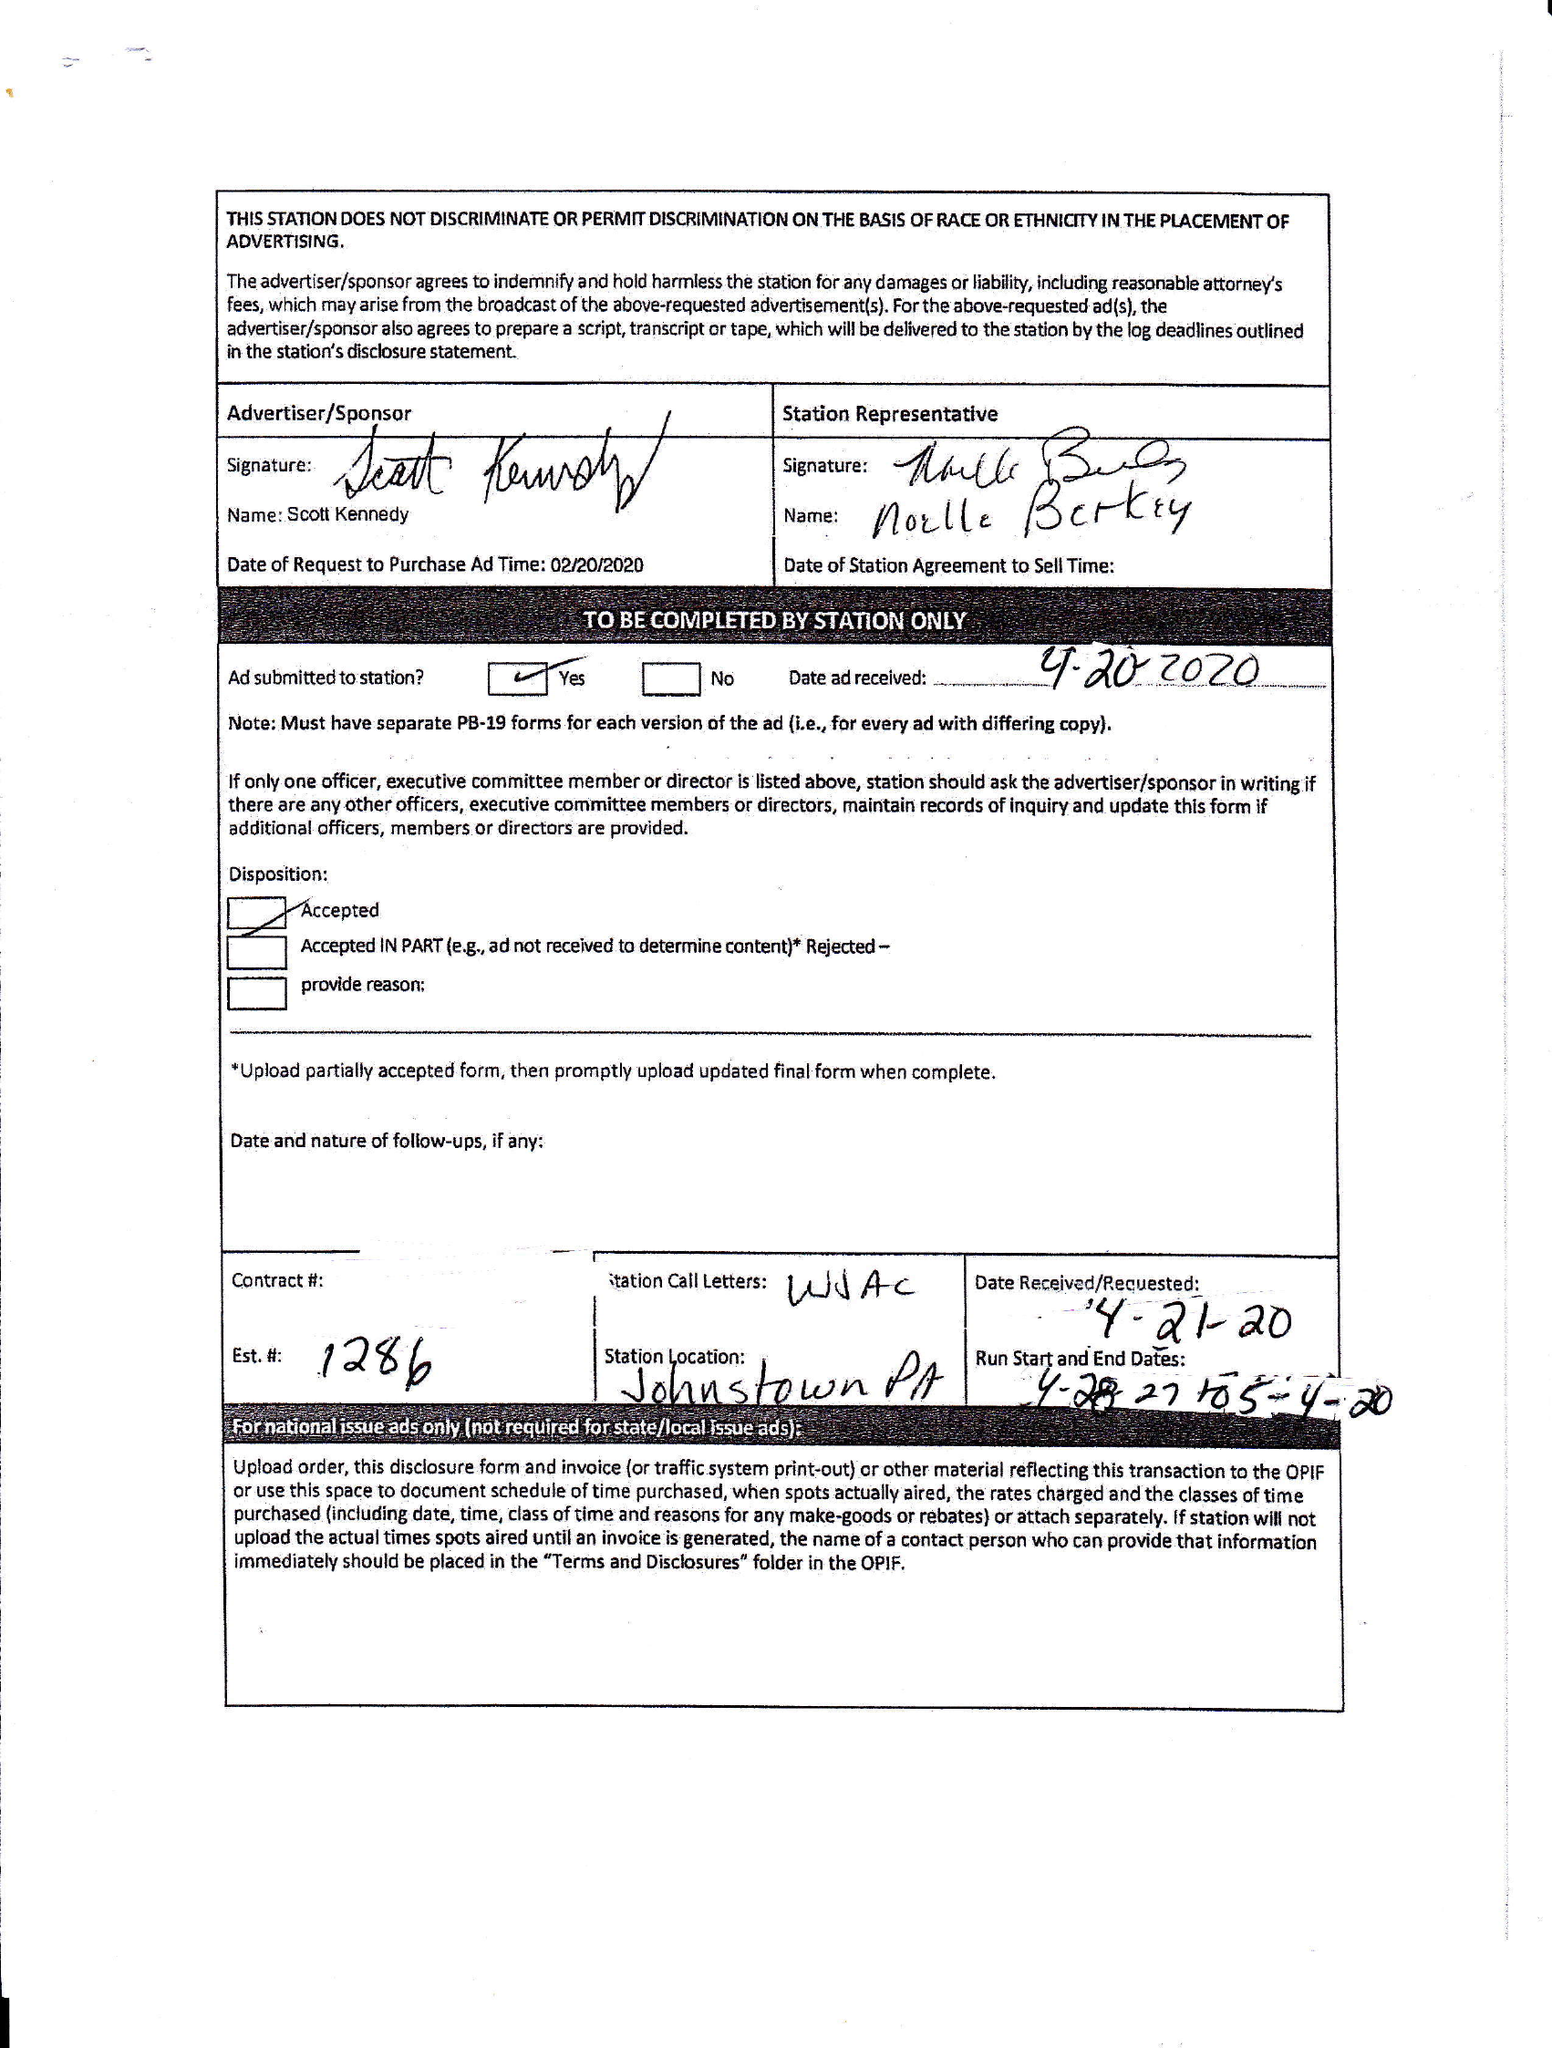What is the value for the flight_from?
Answer the question using a single word or phrase. 04/28/20 